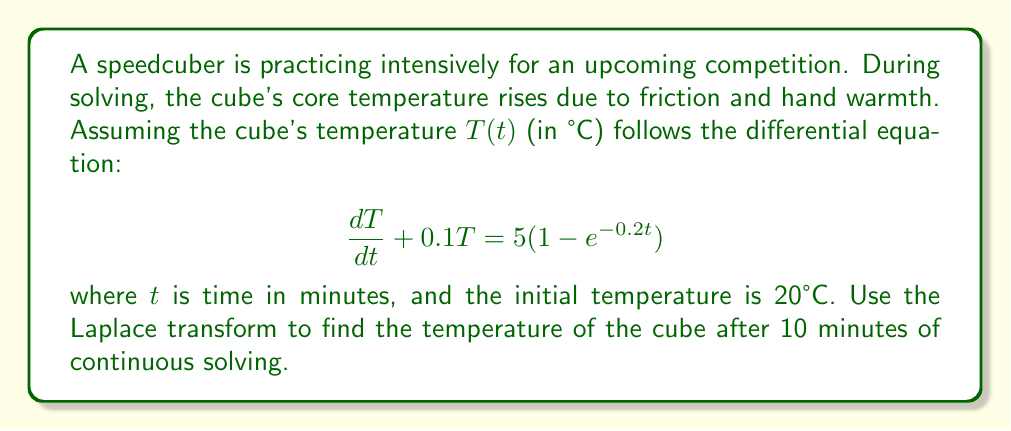Show me your answer to this math problem. Let's solve this step-by-step using the Laplace transform:

1) Take the Laplace transform of both sides of the equation:
   $$\mathcal{L}\{\frac{dT}{dt} + 0.1T\} = \mathcal{L}\{5(1-e^{-0.2t})\}$$

2) Using Laplace transform properties:
   $$s\mathcal{L}\{T\} - T(0) + 0.1\mathcal{L}\{T\} = 5(\frac{1}{s} - \frac{1}{s+0.2})$$

3) Let $\mathcal{L}\{T\} = X(s)$. Substituting $T(0) = 20$:
   $$sX(s) - 20 + 0.1X(s) = 5(\frac{1}{s} - \frac{1}{s+0.2})$$

4) Rearranging:
   $$(s+0.1)X(s) = 20 + 5(\frac{1}{s} - \frac{1}{s+0.2})$$

5) Solving for $X(s)$:
   $$X(s) = \frac{20}{s+0.1} + \frac{5}{s(s+0.1)} - \frac{5}{(s+0.2)(s+0.1)}$$

6) Decompose into partial fractions:
   $$X(s) = \frac{A}{s} + \frac{B}{s+0.1} + \frac{C}{s+0.2}$$

   Where $A = 50$, $B = -30$, and $C = 0$

7) Take the inverse Laplace transform:
   $$T(t) = 50 - 30e^{-0.1t}$$

8) Evaluate at $t = 10$:
   $$T(10) = 50 - 30e^{-0.1(10)} \approx 38.87°C$$
Answer: The temperature of the cube after 10 minutes of continuous solving is approximately 38.87°C. 